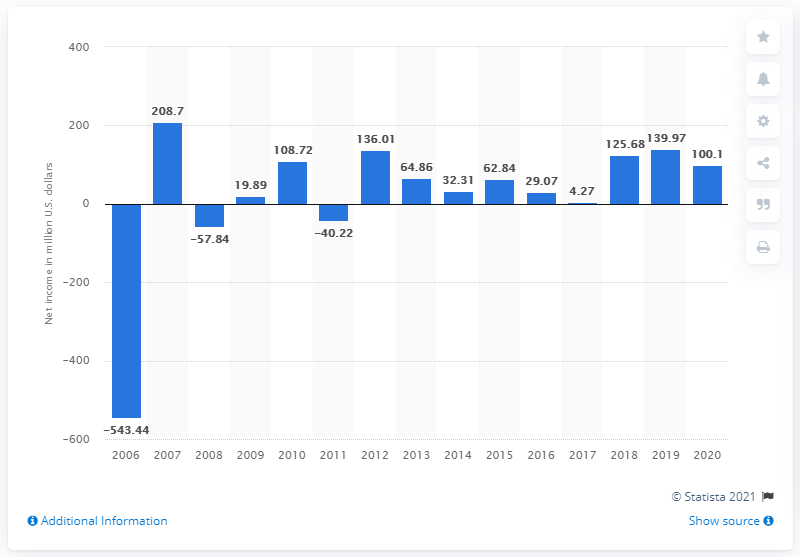Indicate a few pertinent items in this graphic. The New York Times Company's net income in 2020 was $100.1 million. 